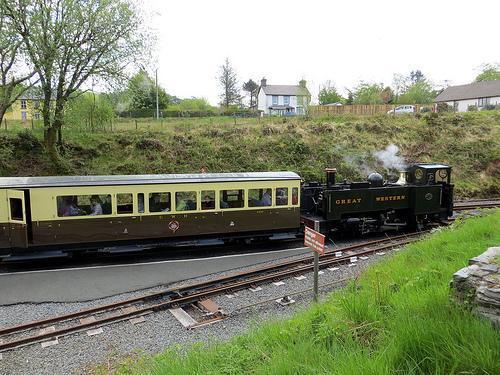How many trains are there?
Give a very brief answer. 1. How many houses are in the background?
Give a very brief answer. 3. 